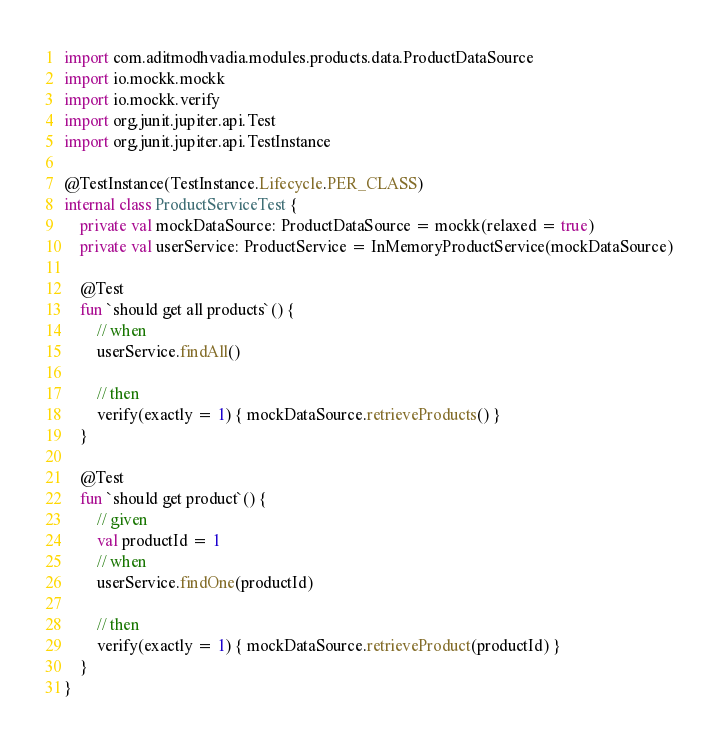Convert code to text. <code><loc_0><loc_0><loc_500><loc_500><_Kotlin_>import com.aditmodhvadia.modules.products.data.ProductDataSource
import io.mockk.mockk
import io.mockk.verify
import org.junit.jupiter.api.Test
import org.junit.jupiter.api.TestInstance

@TestInstance(TestInstance.Lifecycle.PER_CLASS)
internal class ProductServiceTest {
    private val mockDataSource: ProductDataSource = mockk(relaxed = true)
    private val userService: ProductService = InMemoryProductService(mockDataSource)

    @Test
    fun `should get all products`() {
        // when
        userService.findAll()

        // then
        verify(exactly = 1) { mockDataSource.retrieveProducts() }
    }

    @Test
    fun `should get product`() {
        // given
        val productId = 1
        // when
        userService.findOne(productId)

        // then
        verify(exactly = 1) { mockDataSource.retrieveProduct(productId) }
    }
}</code> 